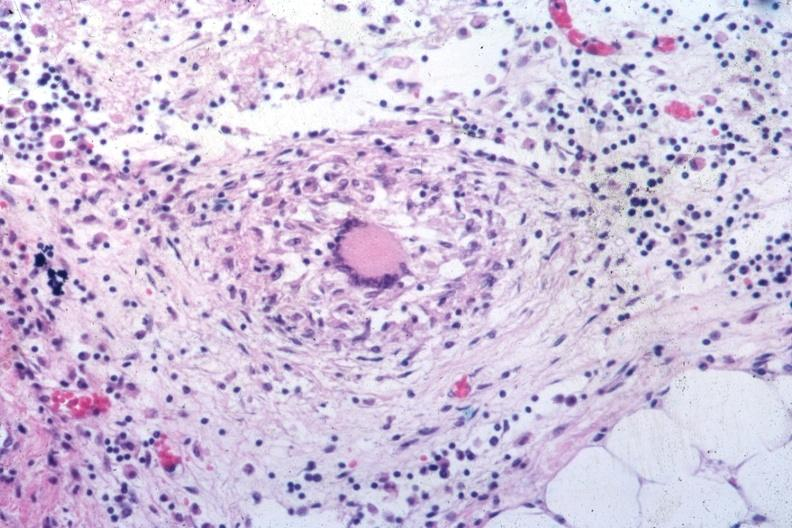s this present?
Answer the question using a single word or phrase. No 